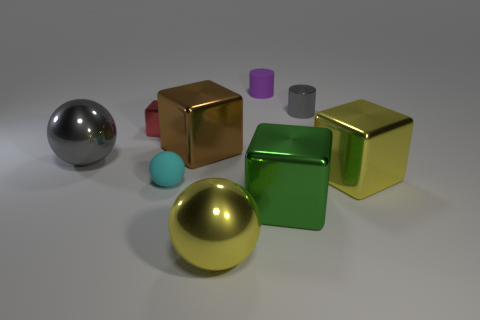Subtract all big yellow metallic spheres. How many spheres are left? 2 Subtract all yellow blocks. How many blocks are left? 3 Subtract all balls. How many objects are left? 6 Add 8 large gray metallic objects. How many large gray metallic objects exist? 9 Add 1 tiny purple matte objects. How many objects exist? 10 Subtract 0 brown cylinders. How many objects are left? 9 Subtract 2 cylinders. How many cylinders are left? 0 Subtract all green blocks. Subtract all brown spheres. How many blocks are left? 3 Subtract all shiny cylinders. Subtract all red blocks. How many objects are left? 7 Add 5 small gray metal things. How many small gray metal things are left? 6 